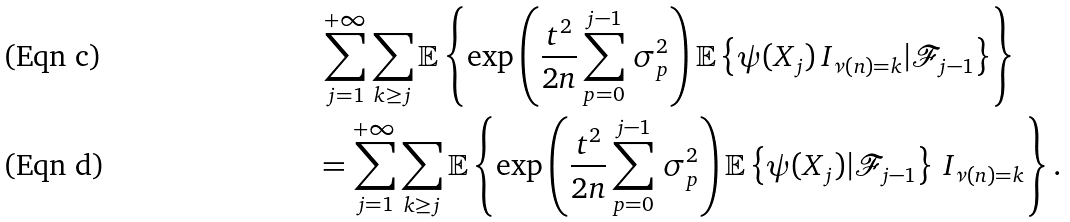<formula> <loc_0><loc_0><loc_500><loc_500>& \, \sum _ { j = 1 } ^ { + \infty } \sum _ { k \geq j } \mathbb { E } \left \{ \exp \left ( \frac { t ^ { 2 } } { 2 n } \sum _ { p = 0 } ^ { j - 1 } \, \sigma _ { p } ^ { 2 } \right ) \mathbb { E } \left \{ \psi ( X _ { j } ) \, I _ { \nu ( n ) = k } | \mathcal { F } _ { j - 1 } \right \} \right \} \\ & = \sum _ { j = 1 } ^ { + \infty } \sum _ { k \geq j } \mathbb { E } \left \{ \exp \left ( \frac { t ^ { 2 } } { 2 n } \sum _ { p = 0 } ^ { j - 1 } \, \sigma _ { p } ^ { 2 } \right ) \mathbb { E } \left \{ \psi ( X _ { j } ) | \mathcal { F } _ { j - 1 } \right \} \, I _ { \nu ( n ) = k } \right \} .</formula> 